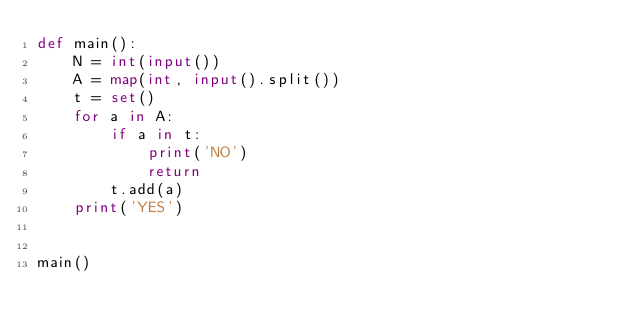<code> <loc_0><loc_0><loc_500><loc_500><_Python_>def main():
    N = int(input())
    A = map(int, input().split())
    t = set()
    for a in A:
        if a in t:
            print('NO')
            return
        t.add(a)
    print('YES')


main()
</code> 